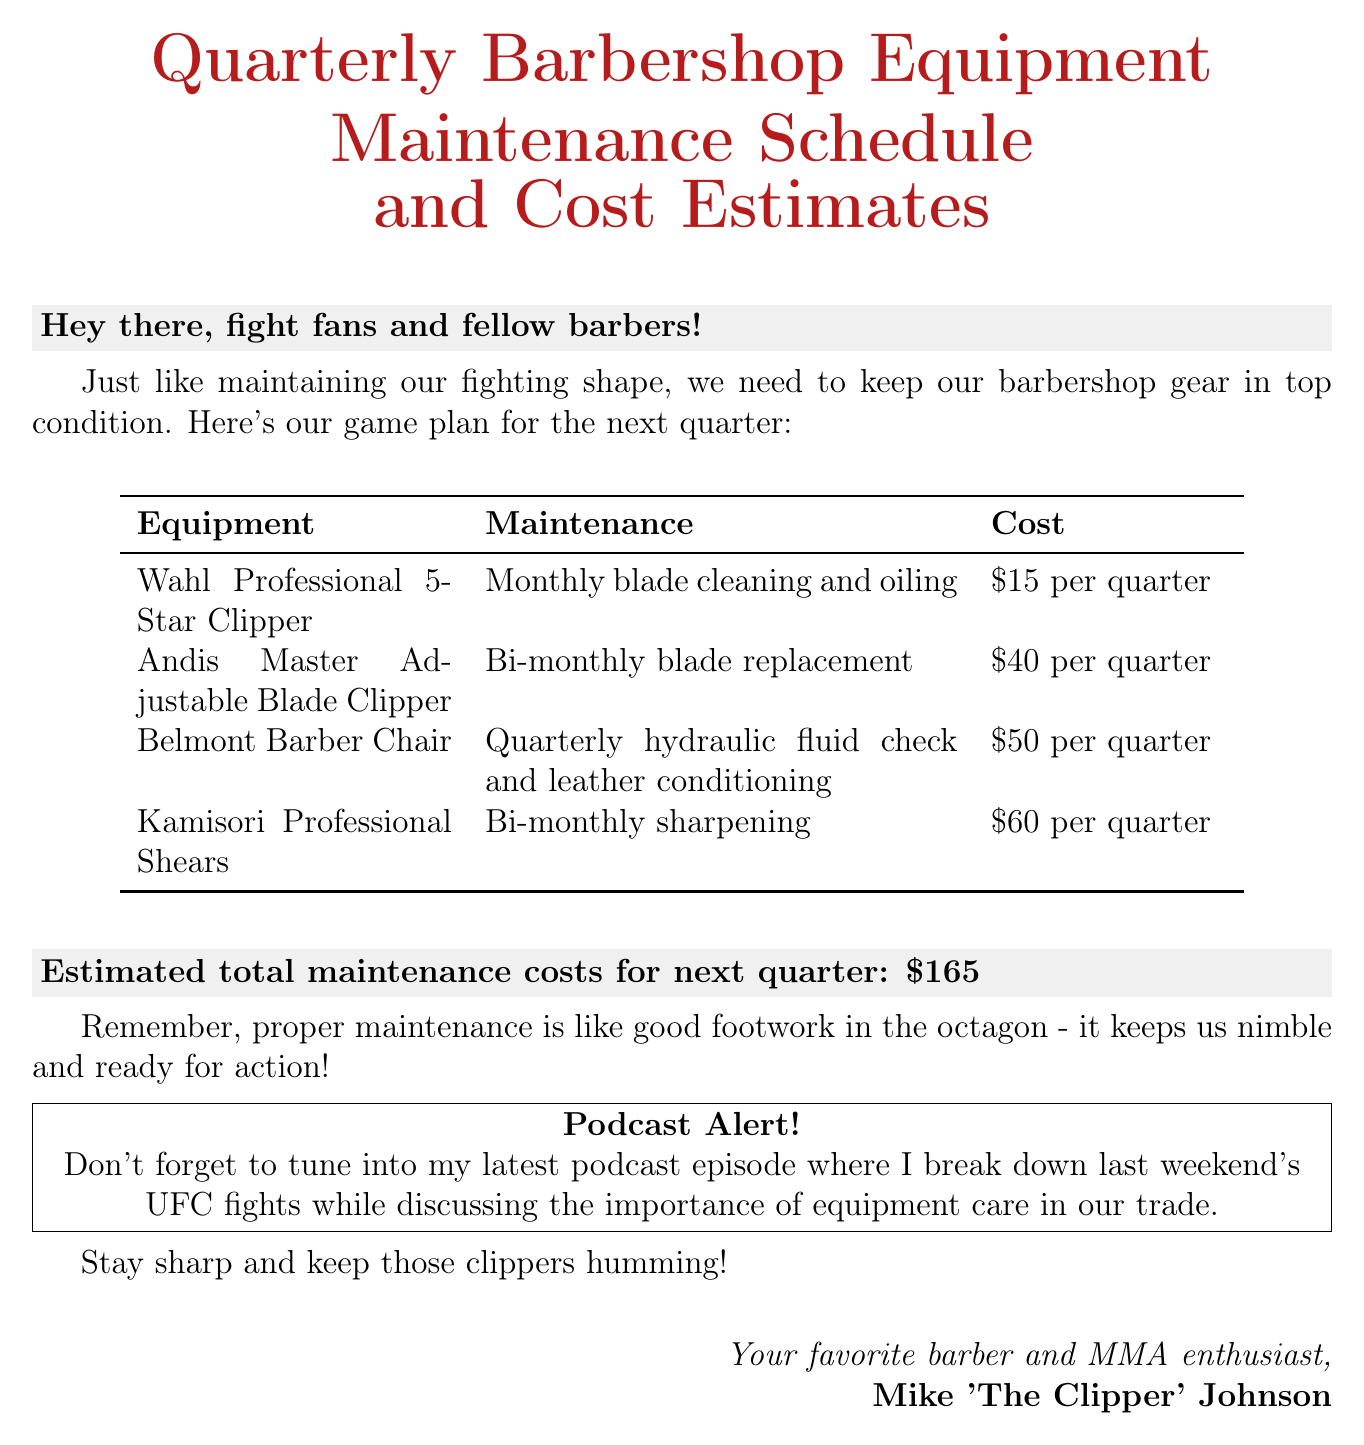What is the subject of the email? The subject provides an overview of what the email is about and is stated as "Quarterly Barbershop Equipment Maintenance Schedule and Cost Estimates."
Answer: Quarterly Barbershop Equipment Maintenance Schedule and Cost Estimates How many pieces of equipment are listed? Count the items detailed in the equipment list to determine the total number of pieces mentioned. There are four items listed in the equipment list.
Answer: 4 What is the maintenance cost for the Wahl Professional 5-Star Clipper? The document specifically states the maintenance cost for this clipper, which is mentioned directly next to the equipment name.
Answer: $15 per quarter Which equipment requires bi-monthly sharpening? The question asks for a specific maintenance routine linked to an item, which can be directly found in the maintenance section.
Answer: Kamisori Professional Shears What is the total estimated maintenance cost for the next quarter? This information is found in the section detailing the overall costs at the end of the equipment list.
Answer: $165 Why is proper maintenance described as important? The email offers a comparison, hinting at the benefits of maintenance by comparing it to a key skill in MMA.
Answer: It keeps us nimble and ready for action What is the name of the podcast host? The document includes the name of the person hosting the podcast and providing the information in the email.
Answer: Mike 'The Clipper' Johnson 